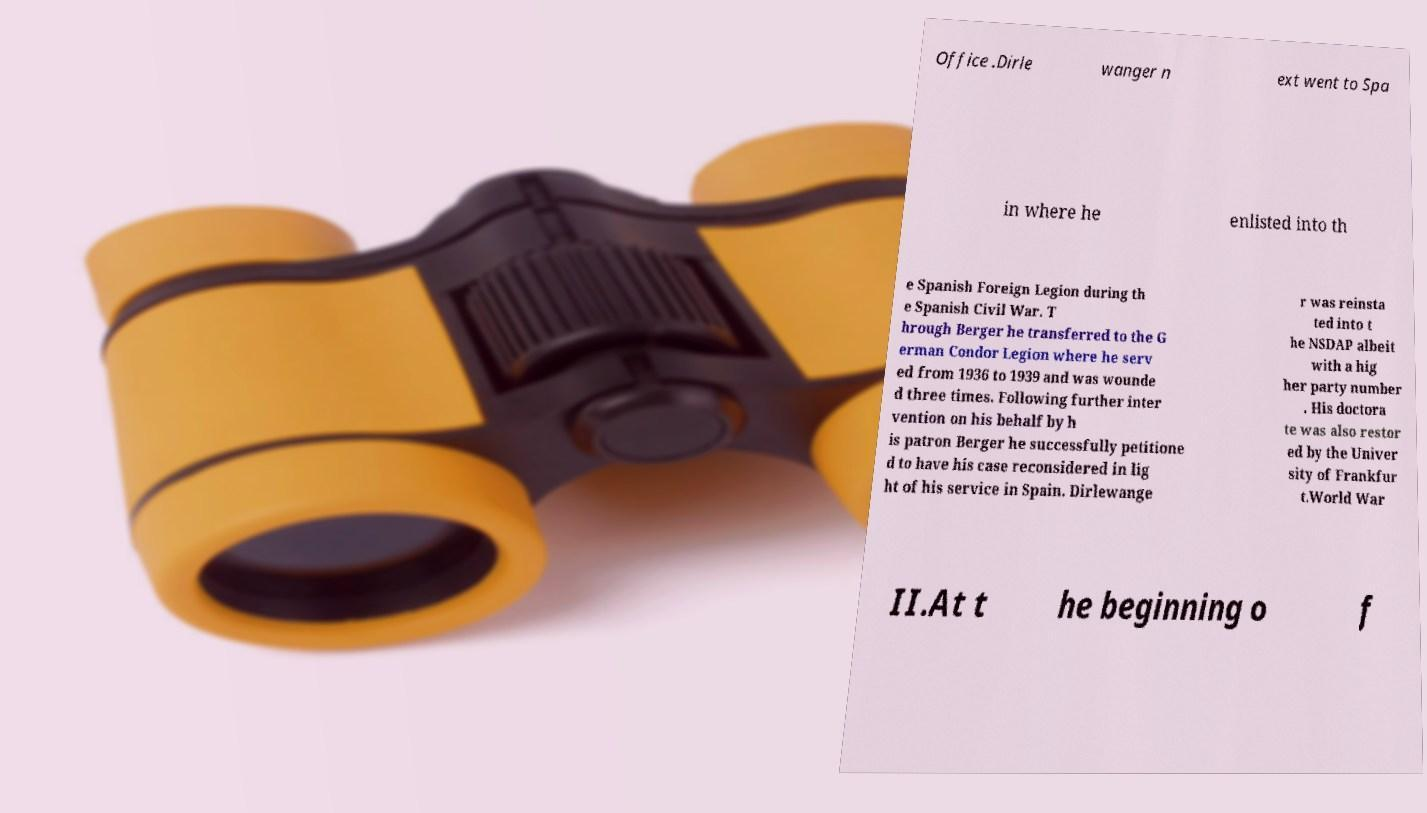There's text embedded in this image that I need extracted. Can you transcribe it verbatim? Office .Dirle wanger n ext went to Spa in where he enlisted into th e Spanish Foreign Legion during th e Spanish Civil War. T hrough Berger he transferred to the G erman Condor Legion where he serv ed from 1936 to 1939 and was wounde d three times. Following further inter vention on his behalf by h is patron Berger he successfully petitione d to have his case reconsidered in lig ht of his service in Spain. Dirlewange r was reinsta ted into t he NSDAP albeit with a hig her party number . His doctora te was also restor ed by the Univer sity of Frankfur t.World War II.At t he beginning o f 